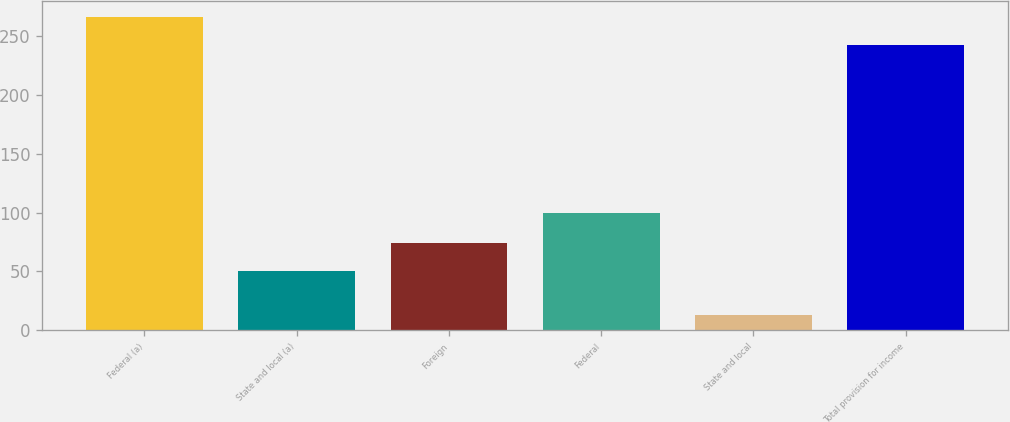Convert chart to OTSL. <chart><loc_0><loc_0><loc_500><loc_500><bar_chart><fcel>Federal (a)<fcel>State and local (a)<fcel>Foreign<fcel>Federal<fcel>State and local<fcel>Total provision for income<nl><fcel>266.19<fcel>50.2<fcel>73.99<fcel>99.2<fcel>12.8<fcel>242.4<nl></chart> 